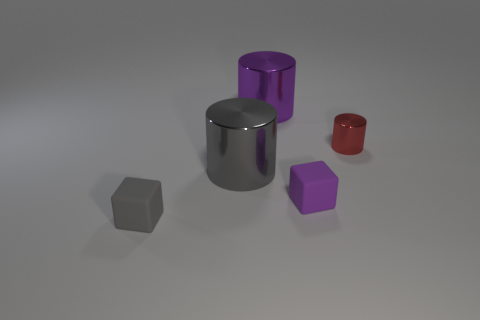Subtract all large gray metallic cylinders. How many cylinders are left? 2 Add 1 gray matte things. How many objects exist? 6 Subtract all purple cylinders. How many cylinders are left? 2 Add 3 gray metal things. How many gray metal things are left? 4 Add 1 big gray balls. How many big gray balls exist? 1 Subtract 1 gray blocks. How many objects are left? 4 Subtract all cubes. How many objects are left? 3 Subtract 3 cylinders. How many cylinders are left? 0 Subtract all blue cubes. Subtract all blue spheres. How many cubes are left? 2 Subtract all red spheres. How many blue cylinders are left? 0 